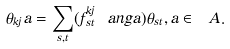<formula> <loc_0><loc_0><loc_500><loc_500>\theta _ { k j } a = \sum _ { s , t } ( f ^ { k j } _ { s t } \ a n g a ) \theta _ { s t } , a \in \ A .</formula> 